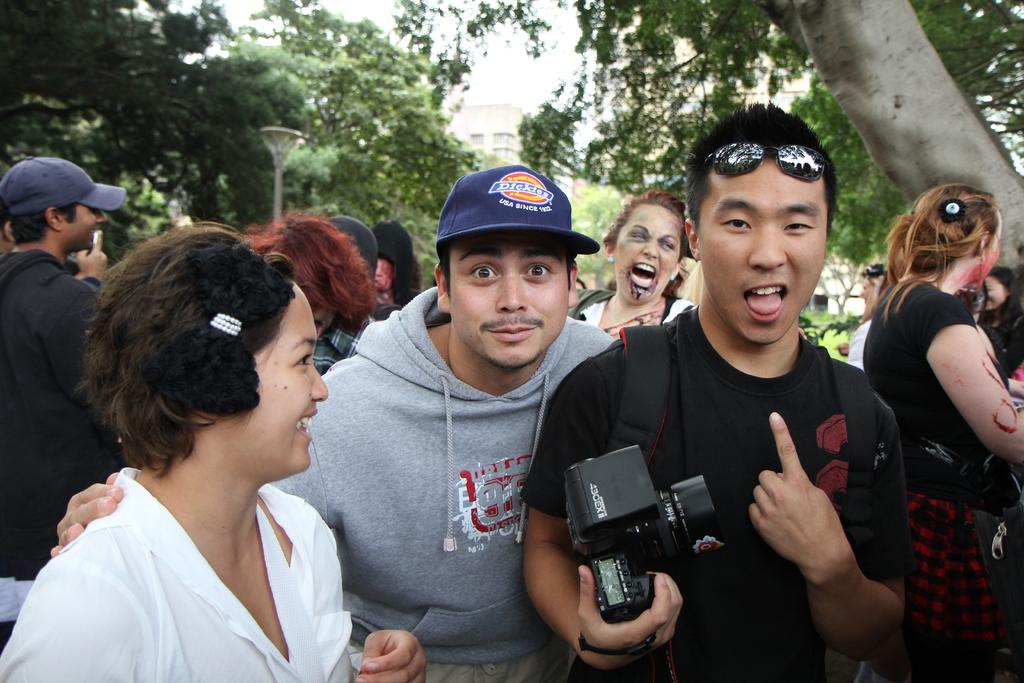How many people are in the image? There is a group of people in the image, but the exact number cannot be determined from the provided facts. What can be seen in the background of the image? There are trees, plants, and a building in the background of the image. What is visible at the top of the image? The sky is visible at the top of the image. Can you see a bat flying in the heart of the image? There is no bat or heart present in the image. 